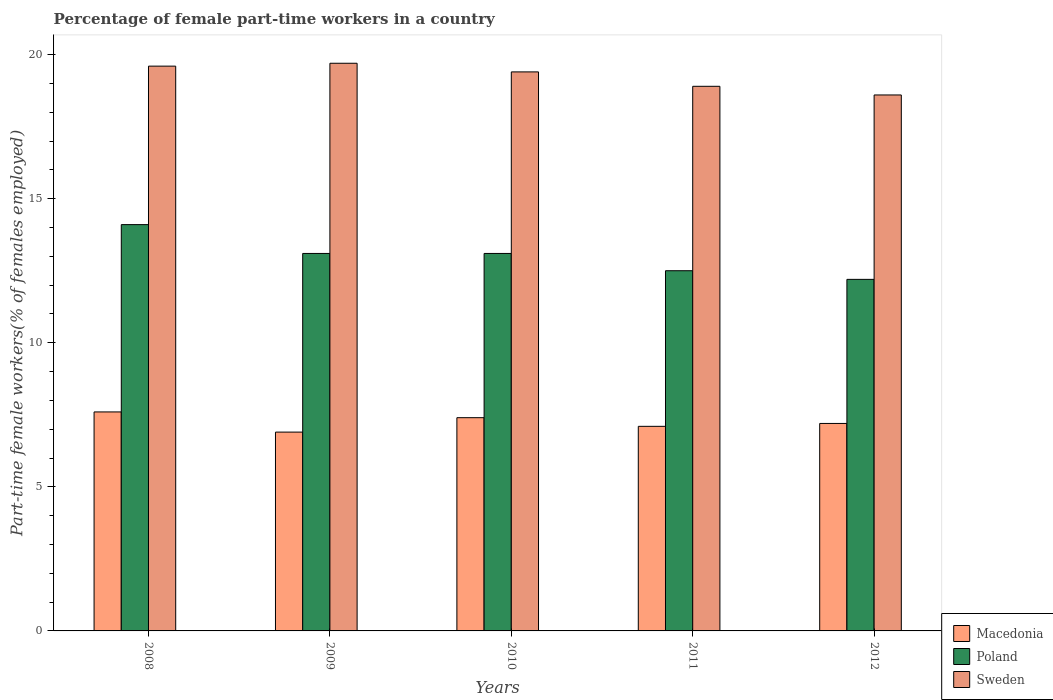Are the number of bars per tick equal to the number of legend labels?
Offer a very short reply. Yes. How many bars are there on the 1st tick from the left?
Offer a very short reply. 3. How many bars are there on the 1st tick from the right?
Ensure brevity in your answer.  3. What is the percentage of female part-time workers in Poland in 2008?
Keep it short and to the point. 14.1. Across all years, what is the maximum percentage of female part-time workers in Sweden?
Offer a terse response. 19.7. Across all years, what is the minimum percentage of female part-time workers in Poland?
Make the answer very short. 12.2. In which year was the percentage of female part-time workers in Sweden maximum?
Your answer should be compact. 2009. What is the total percentage of female part-time workers in Poland in the graph?
Give a very brief answer. 65. What is the difference between the percentage of female part-time workers in Sweden in 2008 and that in 2012?
Your response must be concise. 1. What is the difference between the percentage of female part-time workers in Macedonia in 2010 and the percentage of female part-time workers in Poland in 2009?
Give a very brief answer. -5.7. What is the average percentage of female part-time workers in Sweden per year?
Make the answer very short. 19.24. In the year 2009, what is the difference between the percentage of female part-time workers in Poland and percentage of female part-time workers in Sweden?
Keep it short and to the point. -6.6. In how many years, is the percentage of female part-time workers in Poland greater than 3 %?
Provide a short and direct response. 5. What is the ratio of the percentage of female part-time workers in Poland in 2011 to that in 2012?
Your response must be concise. 1.02. Is the difference between the percentage of female part-time workers in Poland in 2008 and 2009 greater than the difference between the percentage of female part-time workers in Sweden in 2008 and 2009?
Make the answer very short. Yes. What is the difference between the highest and the second highest percentage of female part-time workers in Poland?
Provide a short and direct response. 1. What is the difference between the highest and the lowest percentage of female part-time workers in Sweden?
Keep it short and to the point. 1.1. Is the sum of the percentage of female part-time workers in Macedonia in 2009 and 2010 greater than the maximum percentage of female part-time workers in Poland across all years?
Your answer should be very brief. Yes. What does the 2nd bar from the right in 2011 represents?
Provide a short and direct response. Poland. Is it the case that in every year, the sum of the percentage of female part-time workers in Macedonia and percentage of female part-time workers in Sweden is greater than the percentage of female part-time workers in Poland?
Provide a succinct answer. Yes. How many bars are there?
Your response must be concise. 15. Are all the bars in the graph horizontal?
Keep it short and to the point. No. Are the values on the major ticks of Y-axis written in scientific E-notation?
Make the answer very short. No. Does the graph contain grids?
Offer a very short reply. No. Where does the legend appear in the graph?
Offer a very short reply. Bottom right. What is the title of the graph?
Provide a succinct answer. Percentage of female part-time workers in a country. What is the label or title of the X-axis?
Your answer should be very brief. Years. What is the label or title of the Y-axis?
Keep it short and to the point. Part-time female workers(% of females employed). What is the Part-time female workers(% of females employed) in Macedonia in 2008?
Your answer should be very brief. 7.6. What is the Part-time female workers(% of females employed) of Poland in 2008?
Offer a terse response. 14.1. What is the Part-time female workers(% of females employed) in Sweden in 2008?
Your answer should be very brief. 19.6. What is the Part-time female workers(% of females employed) in Macedonia in 2009?
Provide a succinct answer. 6.9. What is the Part-time female workers(% of females employed) of Poland in 2009?
Your answer should be compact. 13.1. What is the Part-time female workers(% of females employed) in Sweden in 2009?
Your response must be concise. 19.7. What is the Part-time female workers(% of females employed) of Macedonia in 2010?
Provide a short and direct response. 7.4. What is the Part-time female workers(% of females employed) of Poland in 2010?
Your response must be concise. 13.1. What is the Part-time female workers(% of females employed) of Sweden in 2010?
Keep it short and to the point. 19.4. What is the Part-time female workers(% of females employed) in Macedonia in 2011?
Offer a terse response. 7.1. What is the Part-time female workers(% of females employed) in Poland in 2011?
Provide a succinct answer. 12.5. What is the Part-time female workers(% of females employed) in Sweden in 2011?
Offer a terse response. 18.9. What is the Part-time female workers(% of females employed) of Macedonia in 2012?
Offer a terse response. 7.2. What is the Part-time female workers(% of females employed) of Poland in 2012?
Your response must be concise. 12.2. What is the Part-time female workers(% of females employed) of Sweden in 2012?
Provide a succinct answer. 18.6. Across all years, what is the maximum Part-time female workers(% of females employed) in Macedonia?
Give a very brief answer. 7.6. Across all years, what is the maximum Part-time female workers(% of females employed) in Poland?
Provide a short and direct response. 14.1. Across all years, what is the maximum Part-time female workers(% of females employed) of Sweden?
Ensure brevity in your answer.  19.7. Across all years, what is the minimum Part-time female workers(% of females employed) in Macedonia?
Your answer should be very brief. 6.9. Across all years, what is the minimum Part-time female workers(% of females employed) in Poland?
Offer a very short reply. 12.2. Across all years, what is the minimum Part-time female workers(% of females employed) of Sweden?
Make the answer very short. 18.6. What is the total Part-time female workers(% of females employed) of Macedonia in the graph?
Provide a succinct answer. 36.2. What is the total Part-time female workers(% of females employed) of Sweden in the graph?
Provide a succinct answer. 96.2. What is the difference between the Part-time female workers(% of females employed) in Macedonia in 2008 and that in 2009?
Your response must be concise. 0.7. What is the difference between the Part-time female workers(% of females employed) in Poland in 2008 and that in 2009?
Your answer should be very brief. 1. What is the difference between the Part-time female workers(% of females employed) of Sweden in 2008 and that in 2009?
Your answer should be compact. -0.1. What is the difference between the Part-time female workers(% of females employed) in Poland in 2008 and that in 2011?
Your answer should be very brief. 1.6. What is the difference between the Part-time female workers(% of females employed) of Sweden in 2008 and that in 2011?
Provide a succinct answer. 0.7. What is the difference between the Part-time female workers(% of females employed) of Macedonia in 2008 and that in 2012?
Keep it short and to the point. 0.4. What is the difference between the Part-time female workers(% of females employed) of Poland in 2008 and that in 2012?
Your answer should be very brief. 1.9. What is the difference between the Part-time female workers(% of females employed) in Sweden in 2008 and that in 2012?
Offer a very short reply. 1. What is the difference between the Part-time female workers(% of females employed) in Macedonia in 2009 and that in 2010?
Keep it short and to the point. -0.5. What is the difference between the Part-time female workers(% of females employed) of Sweden in 2009 and that in 2010?
Your answer should be very brief. 0.3. What is the difference between the Part-time female workers(% of females employed) of Sweden in 2009 and that in 2011?
Offer a very short reply. 0.8. What is the difference between the Part-time female workers(% of females employed) of Macedonia in 2009 and that in 2012?
Provide a succinct answer. -0.3. What is the difference between the Part-time female workers(% of females employed) of Poland in 2009 and that in 2012?
Ensure brevity in your answer.  0.9. What is the difference between the Part-time female workers(% of females employed) of Sweden in 2010 and that in 2011?
Keep it short and to the point. 0.5. What is the difference between the Part-time female workers(% of females employed) in Macedonia in 2010 and that in 2012?
Keep it short and to the point. 0.2. What is the difference between the Part-time female workers(% of females employed) of Poland in 2010 and that in 2012?
Offer a very short reply. 0.9. What is the difference between the Part-time female workers(% of females employed) of Macedonia in 2008 and the Part-time female workers(% of females employed) of Poland in 2009?
Your answer should be very brief. -5.5. What is the difference between the Part-time female workers(% of females employed) in Macedonia in 2008 and the Part-time female workers(% of females employed) in Sweden in 2009?
Offer a very short reply. -12.1. What is the difference between the Part-time female workers(% of females employed) of Macedonia in 2008 and the Part-time female workers(% of females employed) of Poland in 2010?
Provide a succinct answer. -5.5. What is the difference between the Part-time female workers(% of females employed) in Poland in 2008 and the Part-time female workers(% of females employed) in Sweden in 2010?
Make the answer very short. -5.3. What is the difference between the Part-time female workers(% of females employed) in Macedonia in 2008 and the Part-time female workers(% of females employed) in Poland in 2011?
Give a very brief answer. -4.9. What is the difference between the Part-time female workers(% of females employed) of Macedonia in 2008 and the Part-time female workers(% of females employed) of Sweden in 2012?
Offer a very short reply. -11. What is the difference between the Part-time female workers(% of females employed) of Poland in 2008 and the Part-time female workers(% of females employed) of Sweden in 2012?
Give a very brief answer. -4.5. What is the difference between the Part-time female workers(% of females employed) of Poland in 2009 and the Part-time female workers(% of females employed) of Sweden in 2011?
Keep it short and to the point. -5.8. What is the difference between the Part-time female workers(% of females employed) in Macedonia in 2009 and the Part-time female workers(% of females employed) in Sweden in 2012?
Make the answer very short. -11.7. What is the difference between the Part-time female workers(% of females employed) of Poland in 2009 and the Part-time female workers(% of females employed) of Sweden in 2012?
Your answer should be compact. -5.5. What is the difference between the Part-time female workers(% of females employed) in Macedonia in 2010 and the Part-time female workers(% of females employed) in Poland in 2011?
Provide a short and direct response. -5.1. What is the difference between the Part-time female workers(% of females employed) in Macedonia in 2010 and the Part-time female workers(% of females employed) in Sweden in 2011?
Provide a succinct answer. -11.5. What is the difference between the Part-time female workers(% of females employed) in Macedonia in 2010 and the Part-time female workers(% of females employed) in Sweden in 2012?
Your answer should be very brief. -11.2. What is the difference between the Part-time female workers(% of females employed) in Macedonia in 2011 and the Part-time female workers(% of females employed) in Sweden in 2012?
Offer a very short reply. -11.5. What is the difference between the Part-time female workers(% of females employed) of Poland in 2011 and the Part-time female workers(% of females employed) of Sweden in 2012?
Your response must be concise. -6.1. What is the average Part-time female workers(% of females employed) in Macedonia per year?
Provide a succinct answer. 7.24. What is the average Part-time female workers(% of females employed) in Poland per year?
Keep it short and to the point. 13. What is the average Part-time female workers(% of females employed) of Sweden per year?
Keep it short and to the point. 19.24. In the year 2008, what is the difference between the Part-time female workers(% of females employed) of Macedonia and Part-time female workers(% of females employed) of Poland?
Your answer should be very brief. -6.5. In the year 2008, what is the difference between the Part-time female workers(% of females employed) in Poland and Part-time female workers(% of females employed) in Sweden?
Make the answer very short. -5.5. In the year 2009, what is the difference between the Part-time female workers(% of females employed) in Macedonia and Part-time female workers(% of females employed) in Sweden?
Offer a terse response. -12.8. In the year 2009, what is the difference between the Part-time female workers(% of females employed) of Poland and Part-time female workers(% of females employed) of Sweden?
Offer a terse response. -6.6. In the year 2010, what is the difference between the Part-time female workers(% of females employed) in Macedonia and Part-time female workers(% of females employed) in Poland?
Your answer should be compact. -5.7. In the year 2010, what is the difference between the Part-time female workers(% of females employed) of Macedonia and Part-time female workers(% of females employed) of Sweden?
Keep it short and to the point. -12. In the year 2011, what is the difference between the Part-time female workers(% of females employed) in Macedonia and Part-time female workers(% of females employed) in Sweden?
Offer a terse response. -11.8. In the year 2011, what is the difference between the Part-time female workers(% of females employed) in Poland and Part-time female workers(% of females employed) in Sweden?
Offer a very short reply. -6.4. In the year 2012, what is the difference between the Part-time female workers(% of females employed) in Macedonia and Part-time female workers(% of females employed) in Sweden?
Keep it short and to the point. -11.4. In the year 2012, what is the difference between the Part-time female workers(% of females employed) in Poland and Part-time female workers(% of females employed) in Sweden?
Provide a succinct answer. -6.4. What is the ratio of the Part-time female workers(% of females employed) in Macedonia in 2008 to that in 2009?
Provide a succinct answer. 1.1. What is the ratio of the Part-time female workers(% of females employed) of Poland in 2008 to that in 2009?
Ensure brevity in your answer.  1.08. What is the ratio of the Part-time female workers(% of females employed) in Sweden in 2008 to that in 2009?
Make the answer very short. 0.99. What is the ratio of the Part-time female workers(% of females employed) in Macedonia in 2008 to that in 2010?
Your response must be concise. 1.03. What is the ratio of the Part-time female workers(% of females employed) in Poland in 2008 to that in 2010?
Ensure brevity in your answer.  1.08. What is the ratio of the Part-time female workers(% of females employed) in Sweden in 2008 to that in 2010?
Ensure brevity in your answer.  1.01. What is the ratio of the Part-time female workers(% of females employed) in Macedonia in 2008 to that in 2011?
Give a very brief answer. 1.07. What is the ratio of the Part-time female workers(% of females employed) in Poland in 2008 to that in 2011?
Offer a terse response. 1.13. What is the ratio of the Part-time female workers(% of females employed) of Sweden in 2008 to that in 2011?
Offer a very short reply. 1.04. What is the ratio of the Part-time female workers(% of females employed) of Macedonia in 2008 to that in 2012?
Make the answer very short. 1.06. What is the ratio of the Part-time female workers(% of females employed) of Poland in 2008 to that in 2012?
Provide a succinct answer. 1.16. What is the ratio of the Part-time female workers(% of females employed) in Sweden in 2008 to that in 2012?
Your answer should be very brief. 1.05. What is the ratio of the Part-time female workers(% of females employed) in Macedonia in 2009 to that in 2010?
Keep it short and to the point. 0.93. What is the ratio of the Part-time female workers(% of females employed) of Sweden in 2009 to that in 2010?
Keep it short and to the point. 1.02. What is the ratio of the Part-time female workers(% of females employed) in Macedonia in 2009 to that in 2011?
Offer a terse response. 0.97. What is the ratio of the Part-time female workers(% of females employed) in Poland in 2009 to that in 2011?
Make the answer very short. 1.05. What is the ratio of the Part-time female workers(% of females employed) in Sweden in 2009 to that in 2011?
Provide a short and direct response. 1.04. What is the ratio of the Part-time female workers(% of females employed) in Poland in 2009 to that in 2012?
Provide a short and direct response. 1.07. What is the ratio of the Part-time female workers(% of females employed) in Sweden in 2009 to that in 2012?
Make the answer very short. 1.06. What is the ratio of the Part-time female workers(% of females employed) of Macedonia in 2010 to that in 2011?
Offer a terse response. 1.04. What is the ratio of the Part-time female workers(% of females employed) in Poland in 2010 to that in 2011?
Ensure brevity in your answer.  1.05. What is the ratio of the Part-time female workers(% of females employed) of Sweden in 2010 to that in 2011?
Ensure brevity in your answer.  1.03. What is the ratio of the Part-time female workers(% of females employed) in Macedonia in 2010 to that in 2012?
Your answer should be very brief. 1.03. What is the ratio of the Part-time female workers(% of females employed) of Poland in 2010 to that in 2012?
Keep it short and to the point. 1.07. What is the ratio of the Part-time female workers(% of females employed) of Sweden in 2010 to that in 2012?
Give a very brief answer. 1.04. What is the ratio of the Part-time female workers(% of females employed) of Macedonia in 2011 to that in 2012?
Your response must be concise. 0.99. What is the ratio of the Part-time female workers(% of females employed) of Poland in 2011 to that in 2012?
Make the answer very short. 1.02. What is the ratio of the Part-time female workers(% of females employed) of Sweden in 2011 to that in 2012?
Your answer should be very brief. 1.02. What is the difference between the highest and the second highest Part-time female workers(% of females employed) of Macedonia?
Ensure brevity in your answer.  0.2. What is the difference between the highest and the second highest Part-time female workers(% of females employed) in Sweden?
Provide a succinct answer. 0.1. What is the difference between the highest and the lowest Part-time female workers(% of females employed) of Poland?
Your answer should be very brief. 1.9. 